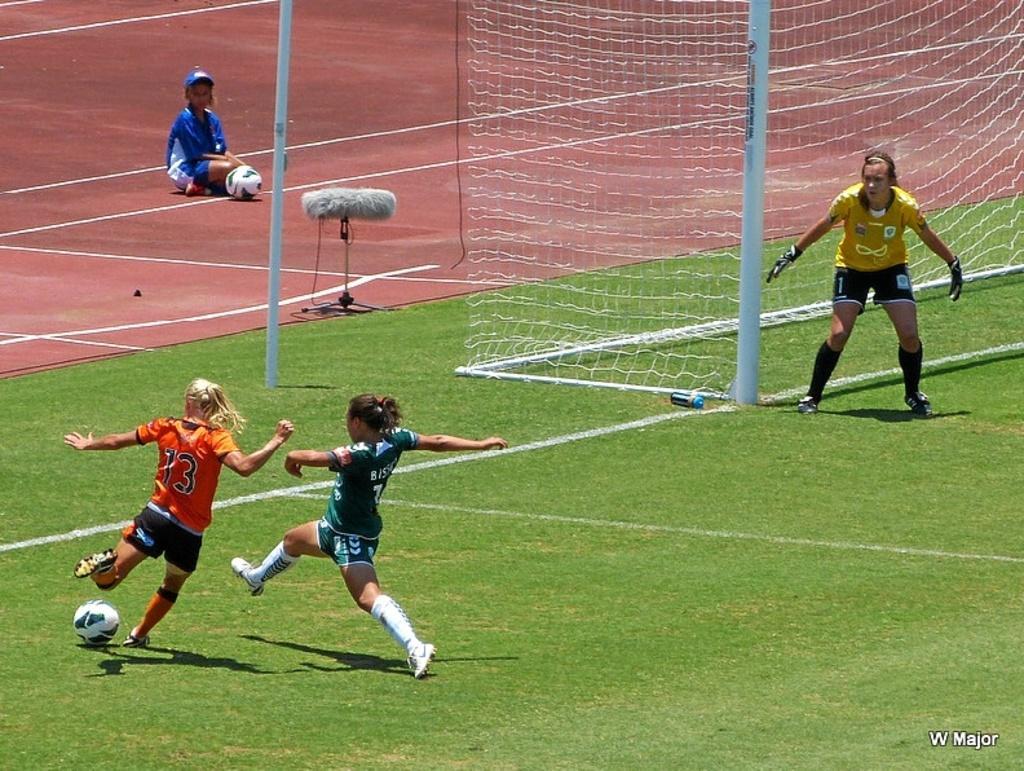In one or two sentences, can you explain what this image depicts? In this image I can see few persons wearing green, orange, black and yellow colored dresses are standing and I can see a ball on the ground. I can see few white colored poles, the net, a person sitting, a ball and the ground in the background. 